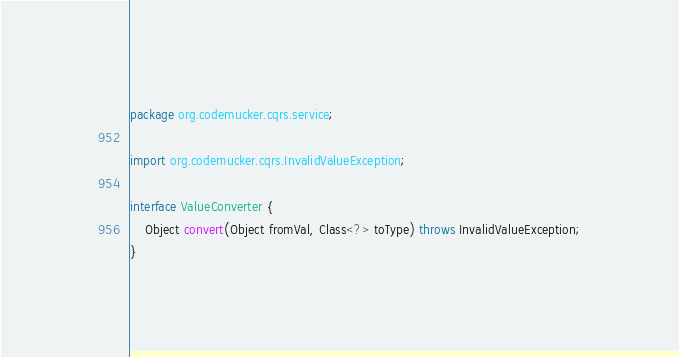Convert code to text. <code><loc_0><loc_0><loc_500><loc_500><_Java_>package org.codemucker.cqrs.service;

import org.codemucker.cqrs.InvalidValueException;

interface ValueConverter {
    Object convert(Object fromVal, Class<?> toType) throws InvalidValueException;
}</code> 